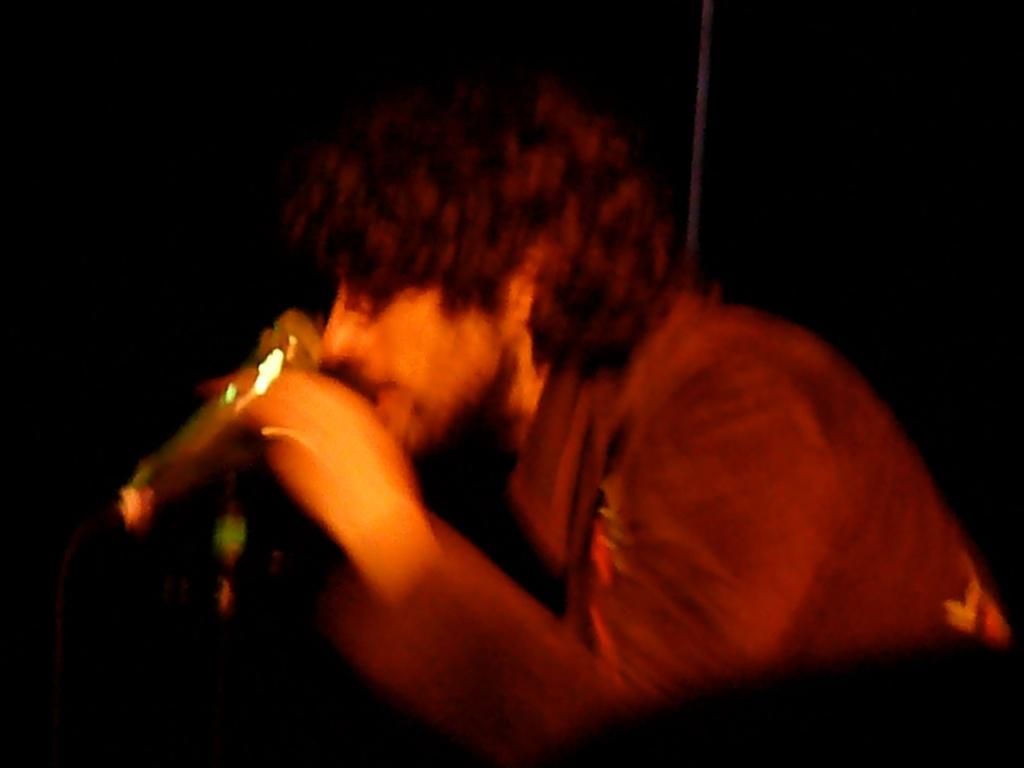What is the main subject of the image? There is a person in the image. What is the person wearing? The person is wearing a brown color shirt. What is the person holding in the image? The person is holding a glass. What is the person doing with the glass? The person is drinking from the glass. How would you describe the background of the image? The background of the image is dark in color. What type of snakes can be seen slithering on the table in the image? There are no snakes present in the image; it features a person holding a glass and drinking. What caused the person to drink from the glass in the image? The facts provided do not mention a cause for the person's action; we can only observe that they are drinking from the glass. 